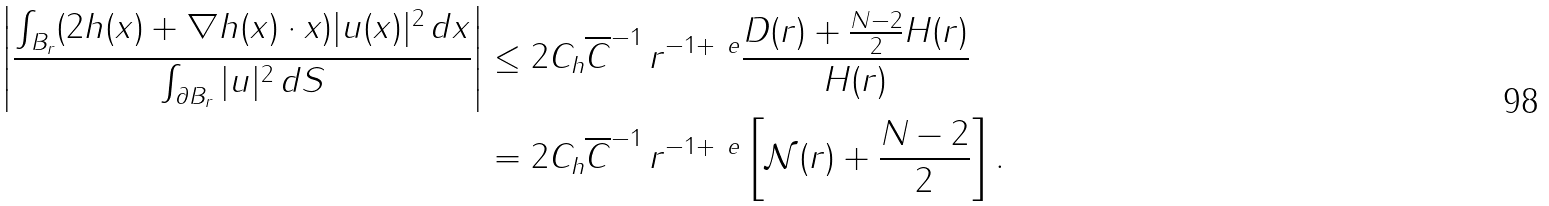Convert formula to latex. <formula><loc_0><loc_0><loc_500><loc_500>\left | \frac { \int _ { B _ { r } } ( 2 h ( x ) + \nabla h ( x ) \cdot x ) | u ( x ) | ^ { 2 } \, d x } { \int _ { \partial B _ { r } } | u | ^ { 2 } \, d S } \right | & \leq 2 C _ { h } \overline { C } ^ { - 1 } \, r ^ { - 1 + \ e } \frac { D ( r ) + \frac { N - 2 } { 2 } H ( r ) } { H ( r ) } \\ & = 2 C _ { h } \overline { C } ^ { - 1 } \, r ^ { - 1 + \ e } \left [ { \mathcal { N } } ( r ) + \frac { N - 2 } { 2 } \right ] .</formula> 